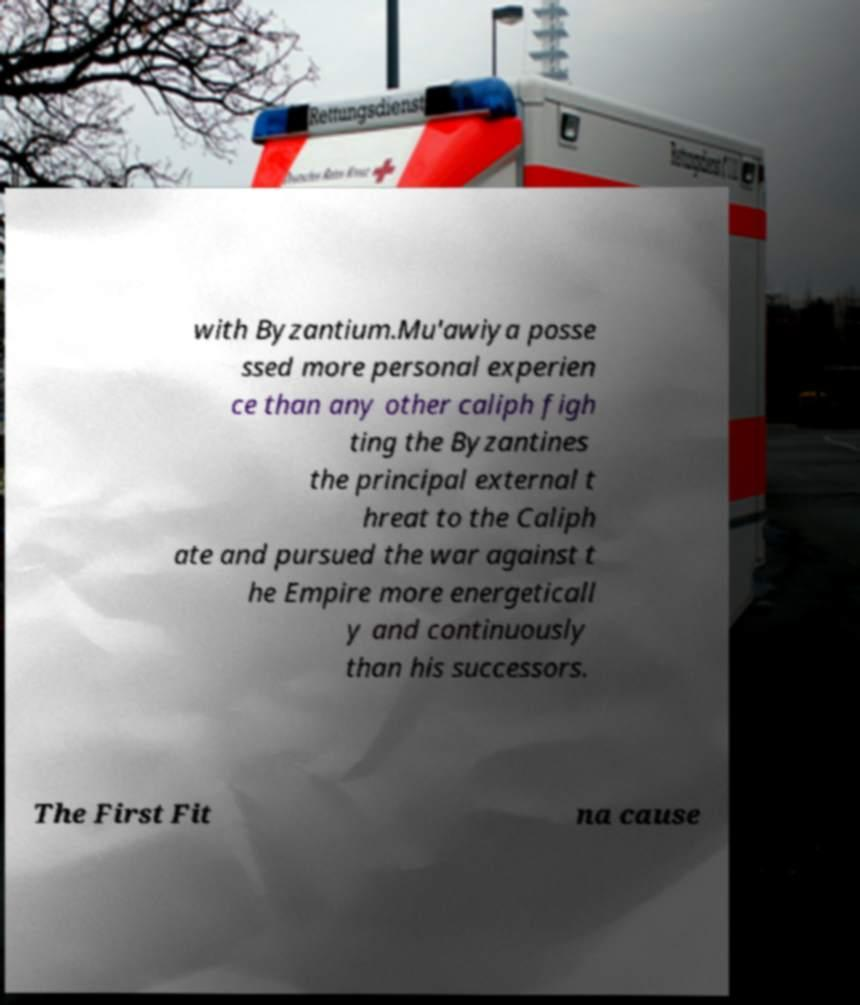There's text embedded in this image that I need extracted. Can you transcribe it verbatim? with Byzantium.Mu'awiya posse ssed more personal experien ce than any other caliph figh ting the Byzantines the principal external t hreat to the Caliph ate and pursued the war against t he Empire more energeticall y and continuously than his successors. The First Fit na cause 